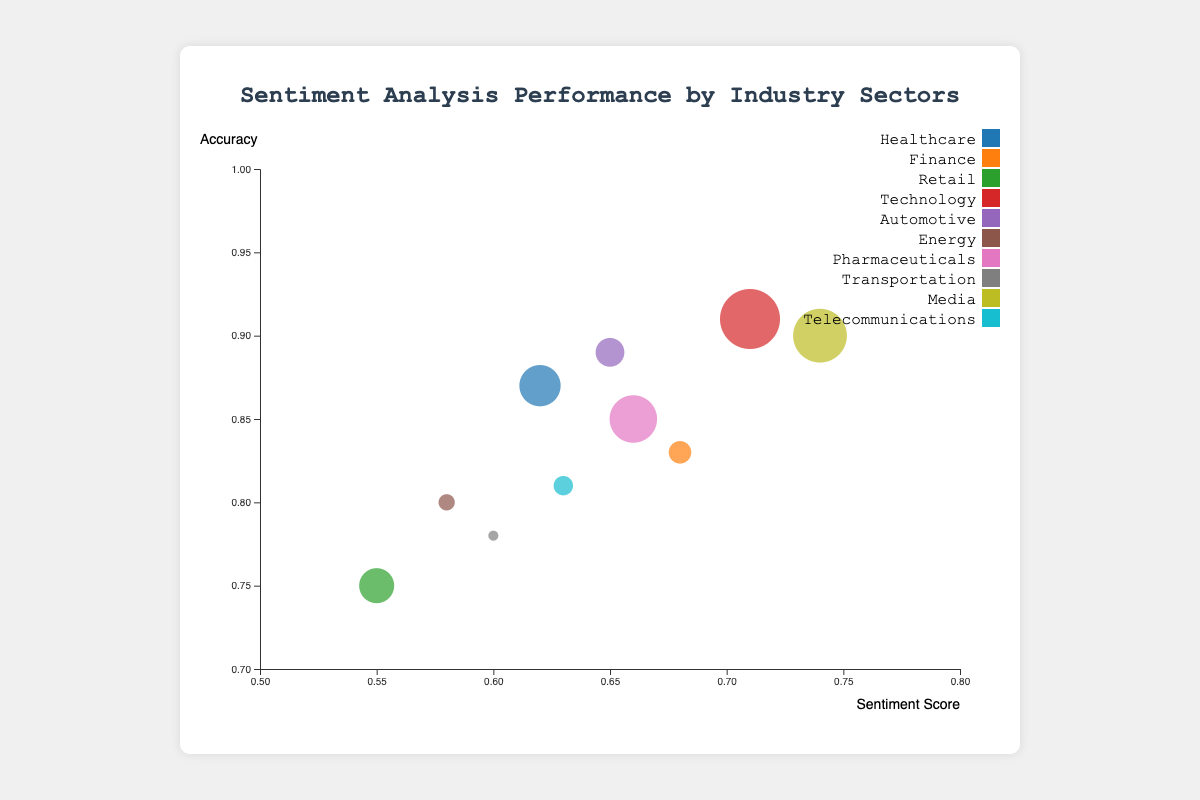What is the industry with the best sentiment score? The bubble chart shows sentiment scores on the x-axis; the highest sentiment score is the farthest to the right. Disney (Media) has the highest sentiment score of 0.74.
Answer: Media How many sectors are represented in the chart? Each unique color in the bubble chart represents a different industry sector. Counting the distinct colors, there are 10 industry sectors: Healthcare, Finance, Retail, Technology, Automotive, Energy, Pharmaceuticals, Transportation, Media, Telecommunications.
Answer: 10 Which company has the largest sample size? The size of each bubble indicates the sample size. The largest bubble, taking up the most space, represents Google (Technology) with a sample size of 1800.
Answer: Google What's the accuracy for Johnson & Johnson in the Healthcare sector? Locate the bubble for Johnson & Johnson in the Healthcare sector and note its position on the y-axis, which corresponds to an accuracy of 0.87.
Answer: 0.87 Compare the sentiment score and accuracy of Google with AT&T. Which company performs better? Google has a sentiment score of 0.71 and accuracy of 0.91; AT&T has a sentiment score of 0.63 and accuracy of 0.81. Google has higher values for both metrics.
Answer: Google Which industry has the lowest accuracy? The bubble with the lowest position on the y-axis indicates the lowest accuracy. Walmart (Retail) has the lowest accuracy of 0.75.
Answer: Retail What is the average sentiment score of the Finance and Energy sectors combined? Goldman Sachs (Finance) has a sentiment score of 0.68, and ExxonMobil (Energy) has a sentiment score of 0.58. The average is (0.68 + 0.58) / 2 = 0.63.
Answer: 0.63 Is there a specific industry that has both high sentiment score and high accuracy? If so, which one? Identify bubbles with both high sentiment scores (right side) and high accuracies (top part). Google (Technology) stands out with a sentiment score of 0.71 and an accuracy of 0.91.
Answer: Technology How do the sentiment scores of Healthcare and Transportation sectors compare, and what does this say about their sentiment analysis performance? Johnson & Johnson (Healthcare) has a sentiment score of 0.62, while Delta Airlines (Transportation) has a sentiment score of 0.60. The Healthcare sector has a slightly higher sentiment score, indicating it performs better in sentiment analysis.
Answer: Healthcare Which industry has the smallest bubble and what does it indicate? The smallest bubble size corresponds to the company with the smallest sample size. Delta Airlines (Transportation) has the smallest bubble, indicating the smallest sample size of 1000.
Answer: Transportation 